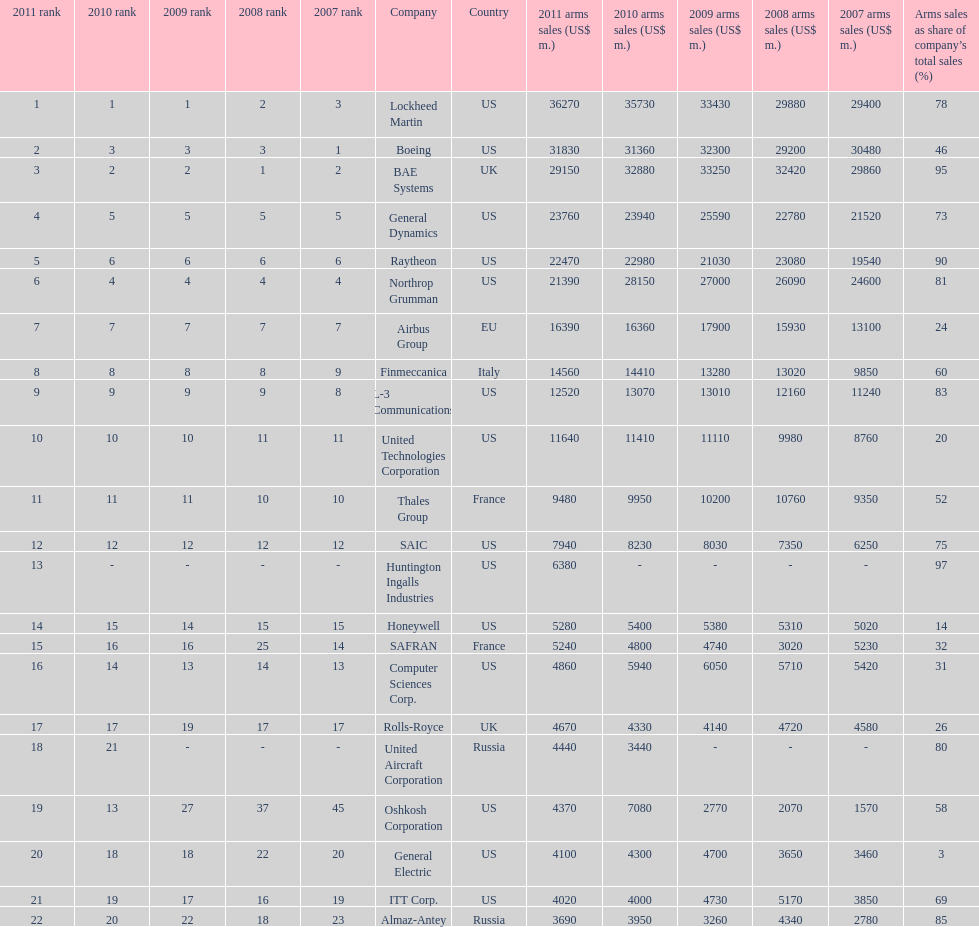How many different countries are listed? 6. 